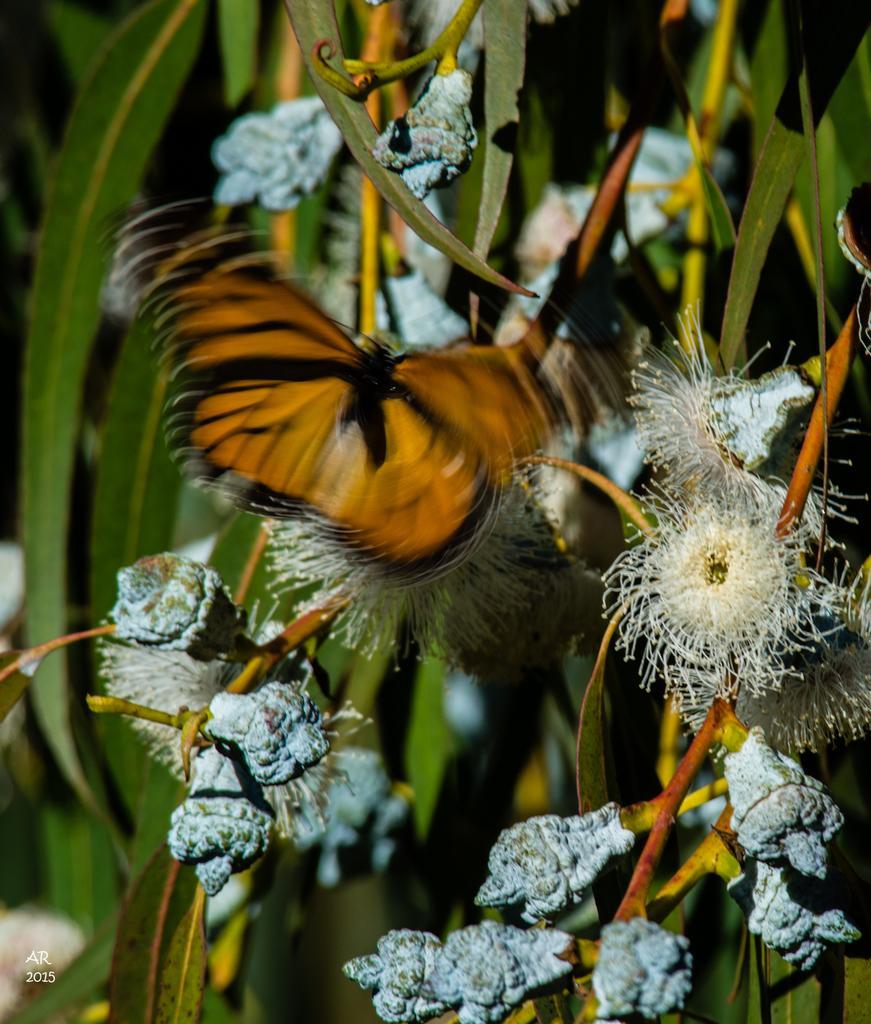Could you give a brief overview of what you see in this image? In the picture I can see butterfly is flying. In the background I can see plants and flowers. The background of the image is blurred. 